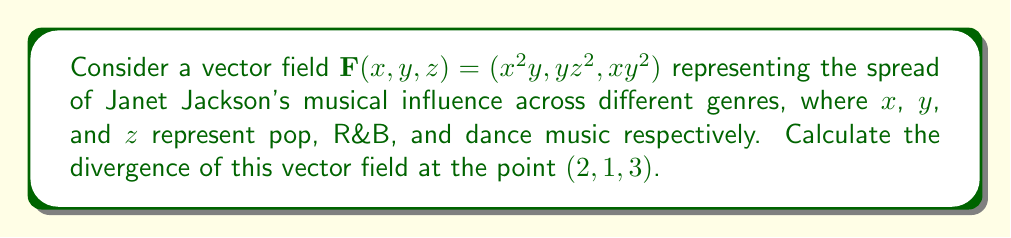Can you solve this math problem? To find the divergence of the vector field $\mathbf{F}(x, y, z) = (x^2y, yz^2, xy^2)$, we need to calculate:

$$\text{div}\mathbf{F} = \nabla \cdot \mathbf{F} = \frac{\partial F_x}{\partial x} + \frac{\partial F_y}{\partial y} + \frac{\partial F_z}{\partial z}$$

Let's calculate each partial derivative:

1) $\frac{\partial F_x}{\partial x} = \frac{\partial}{\partial x}(x^2y) = 2xy$

2) $\frac{\partial F_y}{\partial y} = \frac{\partial}{\partial y}(yz^2) = z^2$

3) $\frac{\partial F_z}{\partial z} = \frac{\partial}{\partial z}(xy^2) = 0$

Now, we sum these partial derivatives:

$$\text{div}\mathbf{F} = 2xy + z^2 + 0 = 2xy + z^2$$

To find the divergence at the point (2, 1, 3), we substitute these values:

$$\text{div}\mathbf{F}(2, 1, 3) = 2(2)(1) + 3^2 = 4 + 9 = 13$$

This positive divergence indicates that Janet Jackson's music is expanding its influence across these genres at the given point.
Answer: 13 